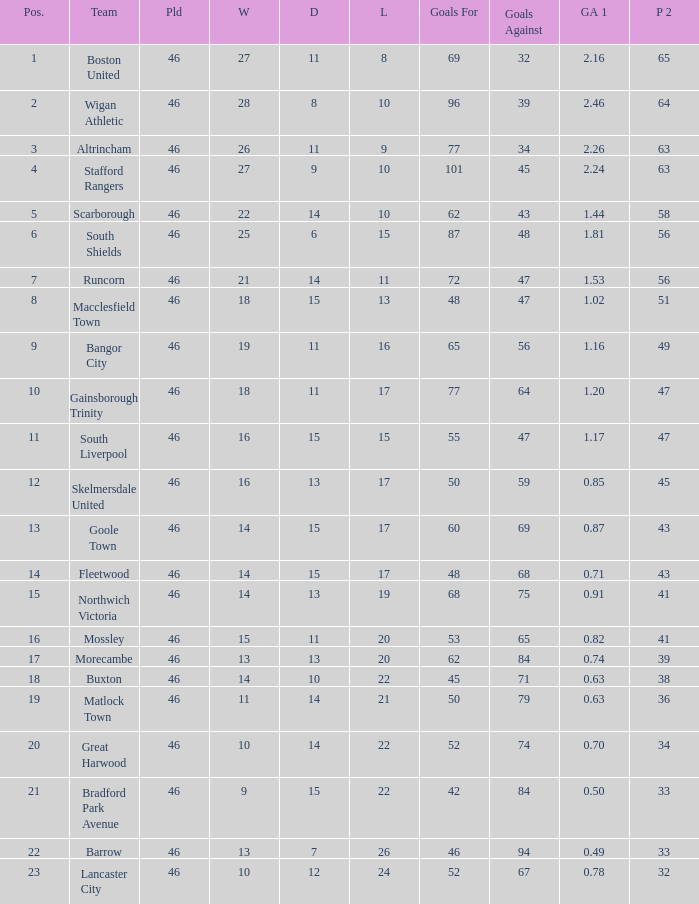How many games did the team who scored 60 goals win? 14.0. 